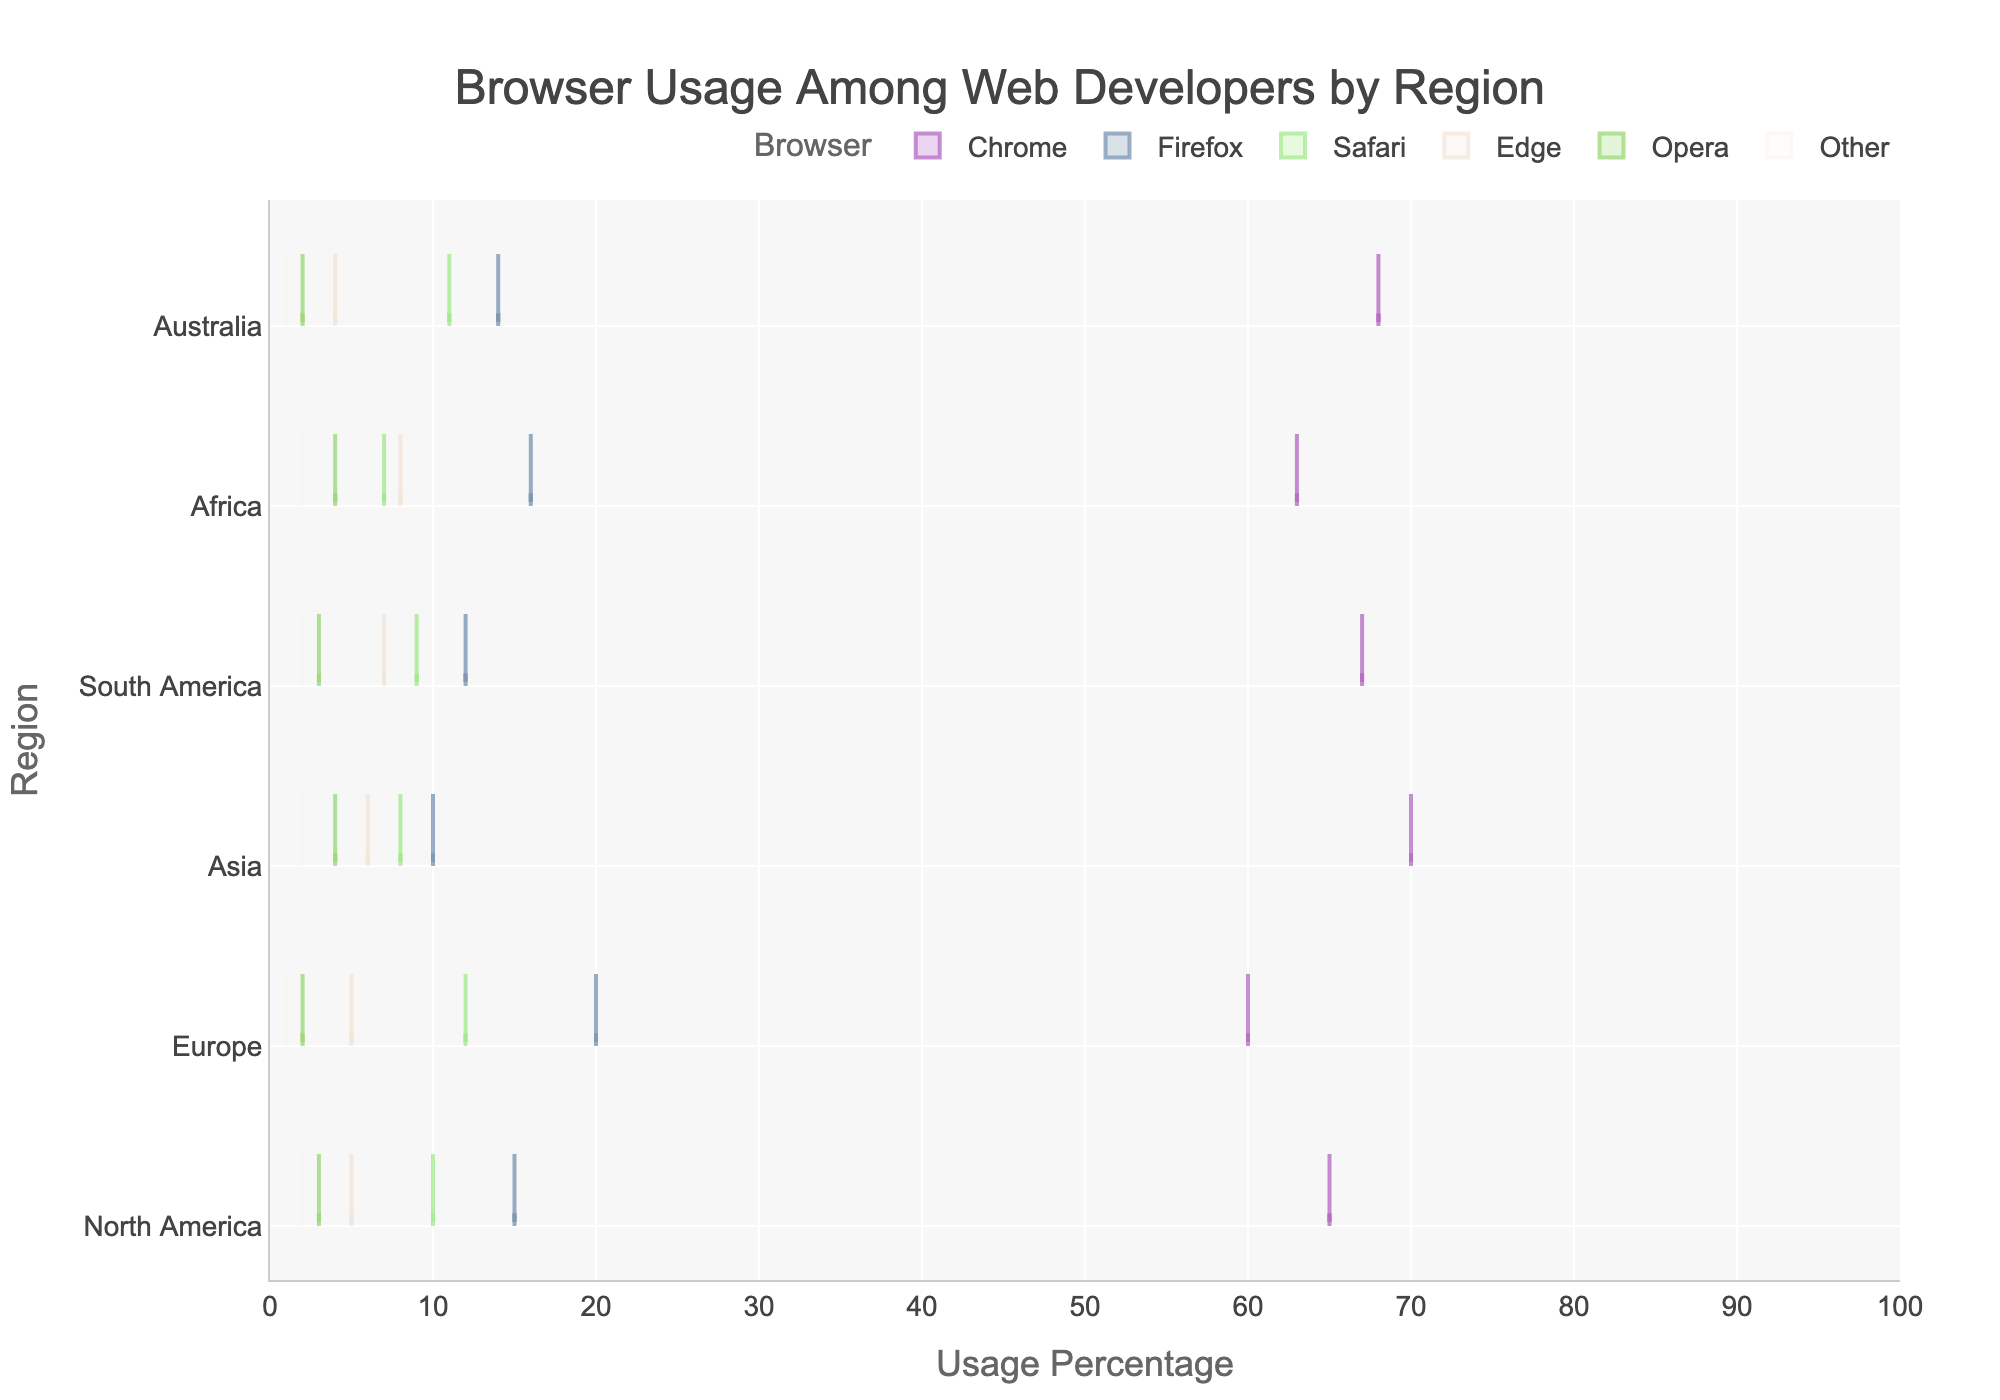What is the title of the horizontal violin chart? The title of the chart is usually located at the top center. In this case, it reads "Browser Usage Among Web Developers by Region".
Answer: Browser Usage Among Web Developers by Region Which browser has the highest usage percentage in Asia? To find the browser with the highest usage in Asia, look for the peak in the corresponding violin plot for Asia. Chrome peaks at the highest percentage.
Answer: Chrome What is the usage percentage of Firefox in Europe? Locate the violin plot for Firefox and identify the point where it intersects with the Europe region. The value is shown directly on the figure.
Answer: 20% Compare the usage percentages of Safari and Opera in North America. Which one is higher? Look at the violin plots for Safari and Opera within the North America section and compare the highest points. Safari is higher.
Answer: Safari What is the average browser usage percentage for Chrome across all regions? Add up the usage percentages for Chrome across all regions and then divide by the number of regions (6). Chrome: (65 + 60 + 70 + 67 + 63 + 68)/6 = 65.5.
Answer: 65.5% Which region shows the highest percentage for the Edge browser? Find the maximum point in the violin plot for Edge across all regions. Africa has the highest value at 8%.
Answer: Africa Compare the overall browser usage trends between North America and Europe. What similarities or differences do you notice? Check both regions' violin plots for each browser. Similarities: Both have Chrome as the most used, followed by Firefox and Safari. Differences: Europe has slightly lower percentages for Chrome and higher for Firefox.
Answer: Similar: Highest for Chrome and Firefox; Different: Proportionally different values What is the total usage percentage of all browsers except Chrome in South America? Sum the usage percentages of all browsers in South America except Chrome. Firefox (12) + Safari (9) + Edge (7) + Opera (3) + Other (2) adds up to 33.
Answer: 33% Which browser has the most consistent usage percentage across all regions? Identify the browser with the least variation in usage percentages across regions by comparing the spread of each violin plot. Edge shows the most consistency with percentages ranging from 4% to 8%.
Answer: Edge What is the range of Safari usage percentages across all regions? Find the minimum and maximum values of Safari usage percentage across all regions and calculate the range. The minimum is 7% (Africa) and the maximum is 12% (Europe). The range is 12 - 7 = 5.
Answer: 5% 